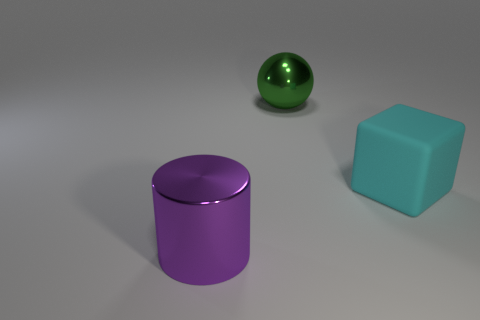Add 2 balls. How many objects exist? 5 Subtract all spheres. How many objects are left? 2 Add 3 small cyan rubber cylinders. How many small cyan rubber cylinders exist? 3 Subtract 1 purple cylinders. How many objects are left? 2 Subtract all green metal spheres. Subtract all big green shiny objects. How many objects are left? 1 Add 2 purple cylinders. How many purple cylinders are left? 3 